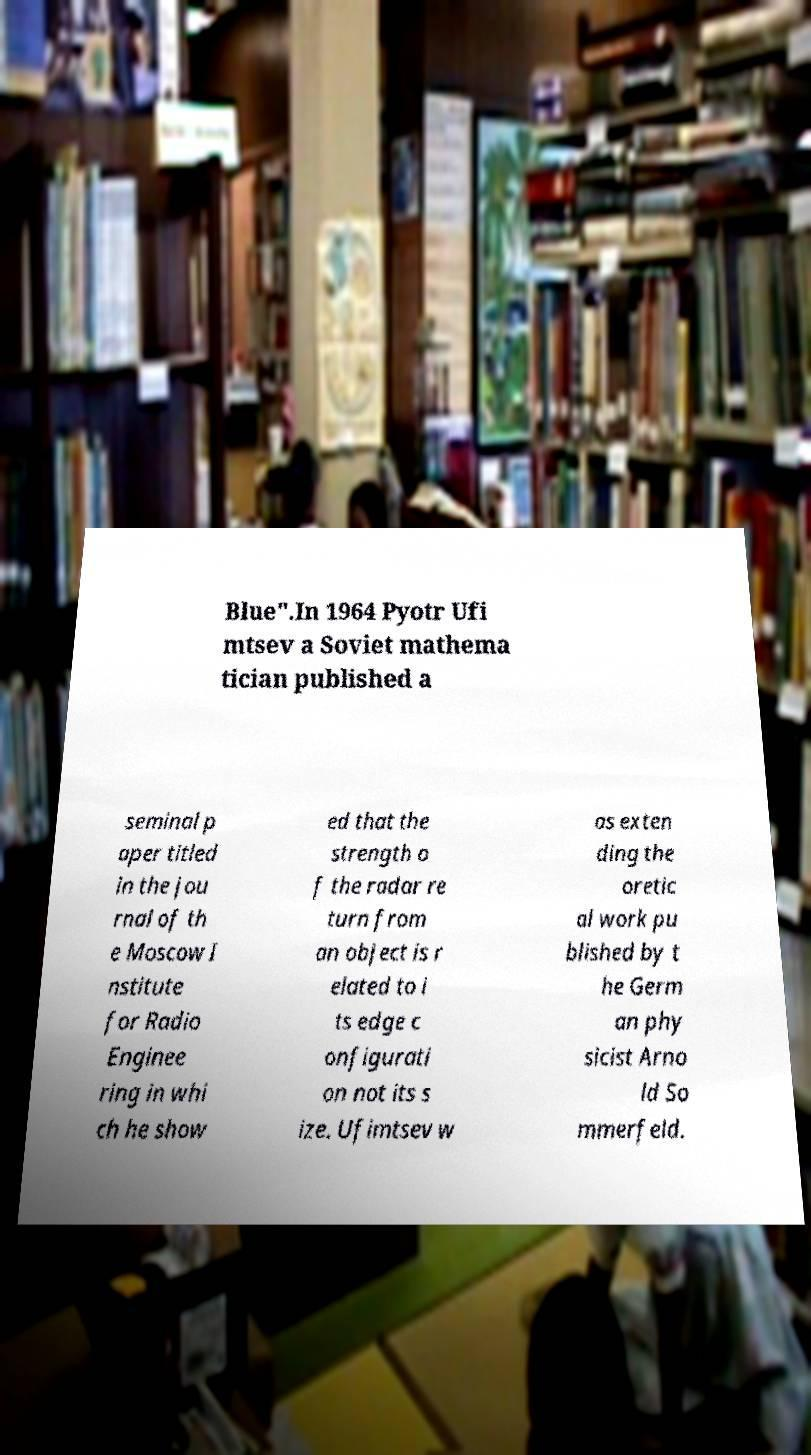For documentation purposes, I need the text within this image transcribed. Could you provide that? Blue".In 1964 Pyotr Ufi mtsev a Soviet mathema tician published a seminal p aper titled in the jou rnal of th e Moscow I nstitute for Radio Enginee ring in whi ch he show ed that the strength o f the radar re turn from an object is r elated to i ts edge c onfigurati on not its s ize. Ufimtsev w as exten ding the oretic al work pu blished by t he Germ an phy sicist Arno ld So mmerfeld. 